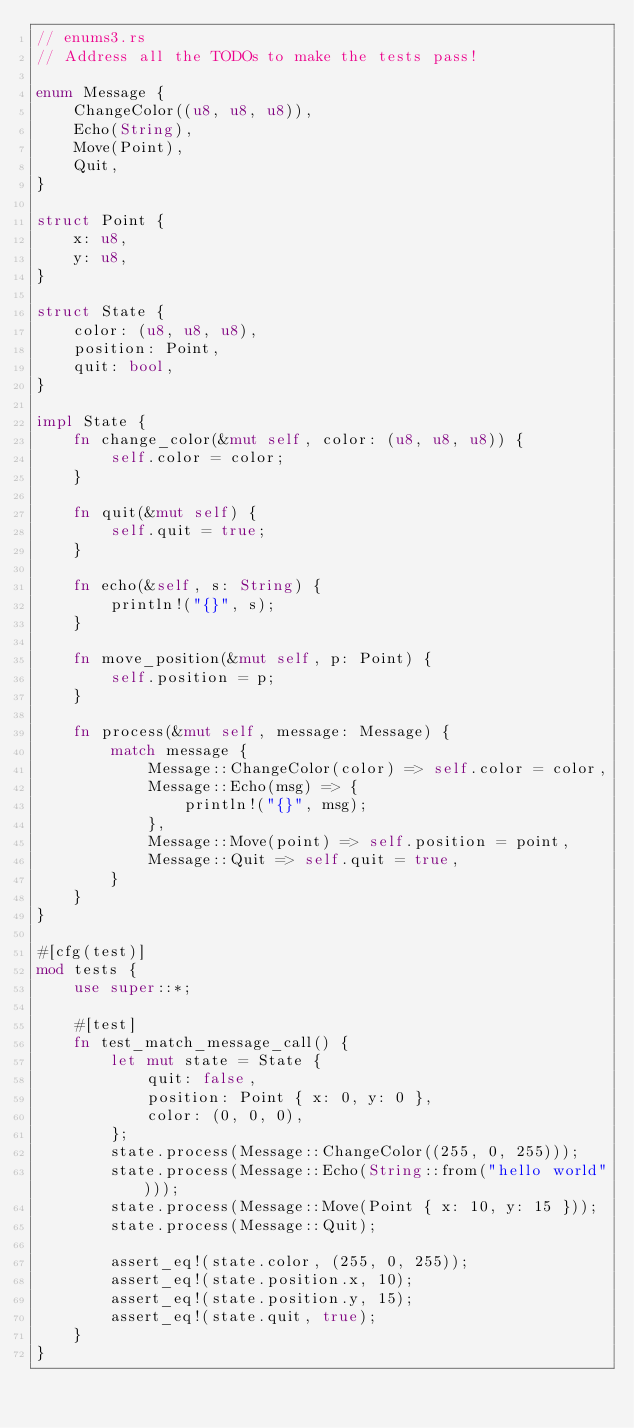Convert code to text. <code><loc_0><loc_0><loc_500><loc_500><_Rust_>// enums3.rs
// Address all the TODOs to make the tests pass!

enum Message {
    ChangeColor((u8, u8, u8)),
    Echo(String),
    Move(Point),
    Quit,
}

struct Point {
    x: u8,
    y: u8,
}

struct State {
    color: (u8, u8, u8),
    position: Point,
    quit: bool,
}

impl State {
    fn change_color(&mut self, color: (u8, u8, u8)) {
        self.color = color;
    }

    fn quit(&mut self) {
        self.quit = true;
    }

    fn echo(&self, s: String) {
        println!("{}", s);
    }

    fn move_position(&mut self, p: Point) {
        self.position = p;
    }

    fn process(&mut self, message: Message) {
        match message {
            Message::ChangeColor(color) => self.color = color,
            Message::Echo(msg) => {
                println!("{}", msg);
            },
            Message::Move(point) => self.position = point,
            Message::Quit => self.quit = true,
        }
    }
}

#[cfg(test)]
mod tests {
    use super::*;

    #[test]
    fn test_match_message_call() {
        let mut state = State {
            quit: false,
            position: Point { x: 0, y: 0 },
            color: (0, 0, 0),
        };
        state.process(Message::ChangeColor((255, 0, 255)));
        state.process(Message::Echo(String::from("hello world")));
        state.process(Message::Move(Point { x: 10, y: 15 }));
        state.process(Message::Quit);

        assert_eq!(state.color, (255, 0, 255));
        assert_eq!(state.position.x, 10);
        assert_eq!(state.position.y, 15);
        assert_eq!(state.quit, true);
    }
}
</code> 